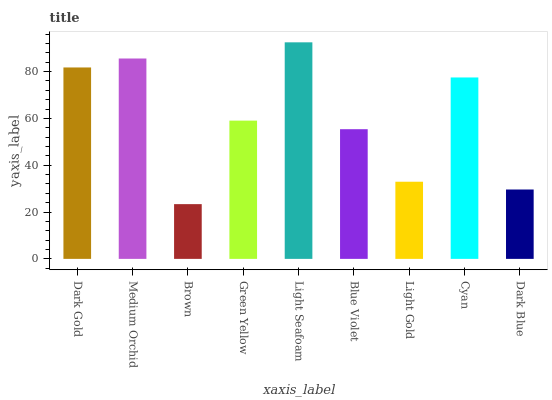Is Brown the minimum?
Answer yes or no. Yes. Is Light Seafoam the maximum?
Answer yes or no. Yes. Is Medium Orchid the minimum?
Answer yes or no. No. Is Medium Orchid the maximum?
Answer yes or no. No. Is Medium Orchid greater than Dark Gold?
Answer yes or no. Yes. Is Dark Gold less than Medium Orchid?
Answer yes or no. Yes. Is Dark Gold greater than Medium Orchid?
Answer yes or no. No. Is Medium Orchid less than Dark Gold?
Answer yes or no. No. Is Green Yellow the high median?
Answer yes or no. Yes. Is Green Yellow the low median?
Answer yes or no. Yes. Is Dark Gold the high median?
Answer yes or no. No. Is Light Seafoam the low median?
Answer yes or no. No. 